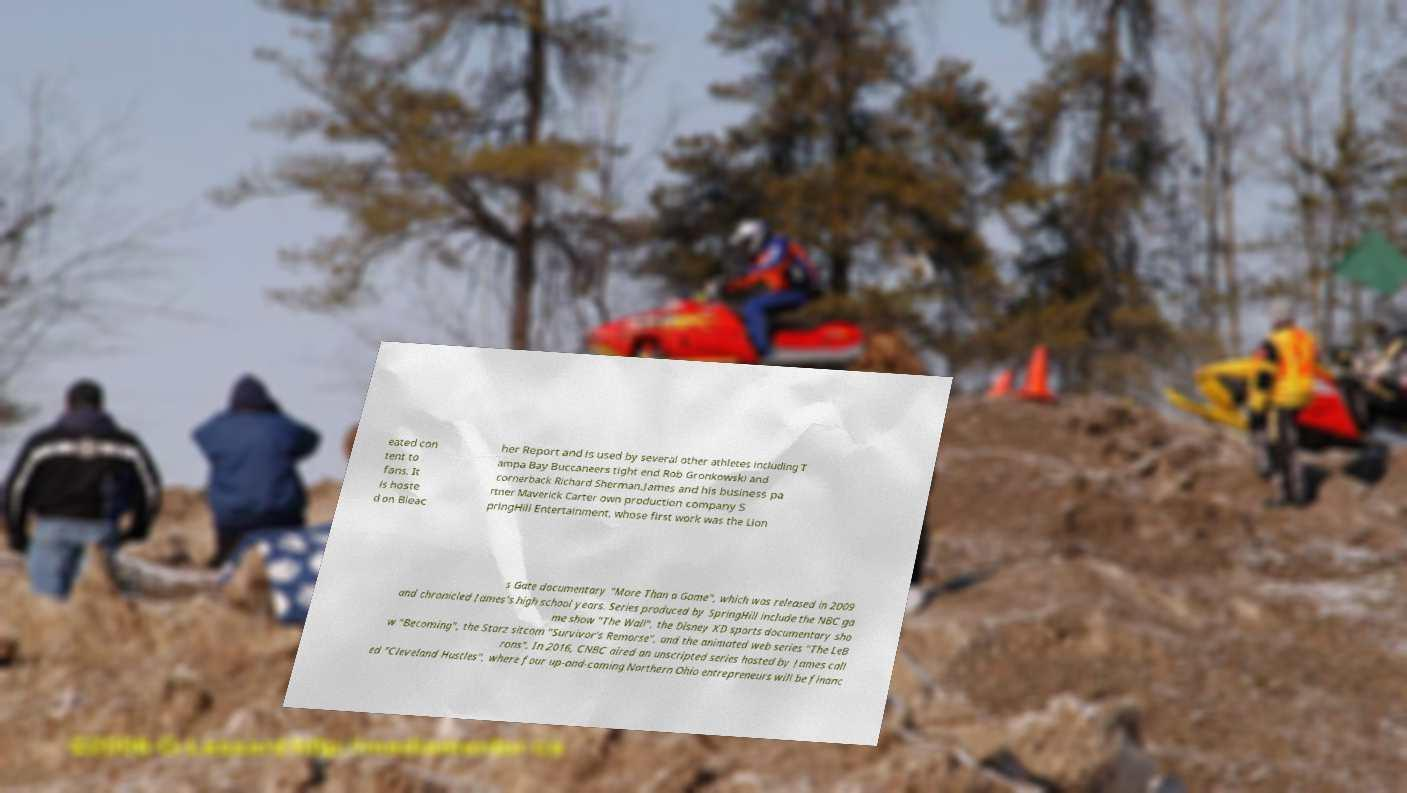Could you extract and type out the text from this image? eated con tent to fans. It is hoste d on Bleac her Report and is used by several other athletes including T ampa Bay Buccaneers tight end Rob Gronkowski and cornerback Richard Sherman.James and his business pa rtner Maverick Carter own production company S pringHill Entertainment, whose first work was the Lion s Gate documentary "More Than a Game", which was released in 2009 and chronicled James's high school years. Series produced by SpringHill include the NBC ga me show "The Wall", the Disney XD sports documentary sho w "Becoming", the Starz sitcom "Survivor's Remorse", and the animated web series "The LeB rons". In 2016, CNBC aired an unscripted series hosted by James call ed "Cleveland Hustles", where four up-and-coming Northern Ohio entrepreneurs will be financ 